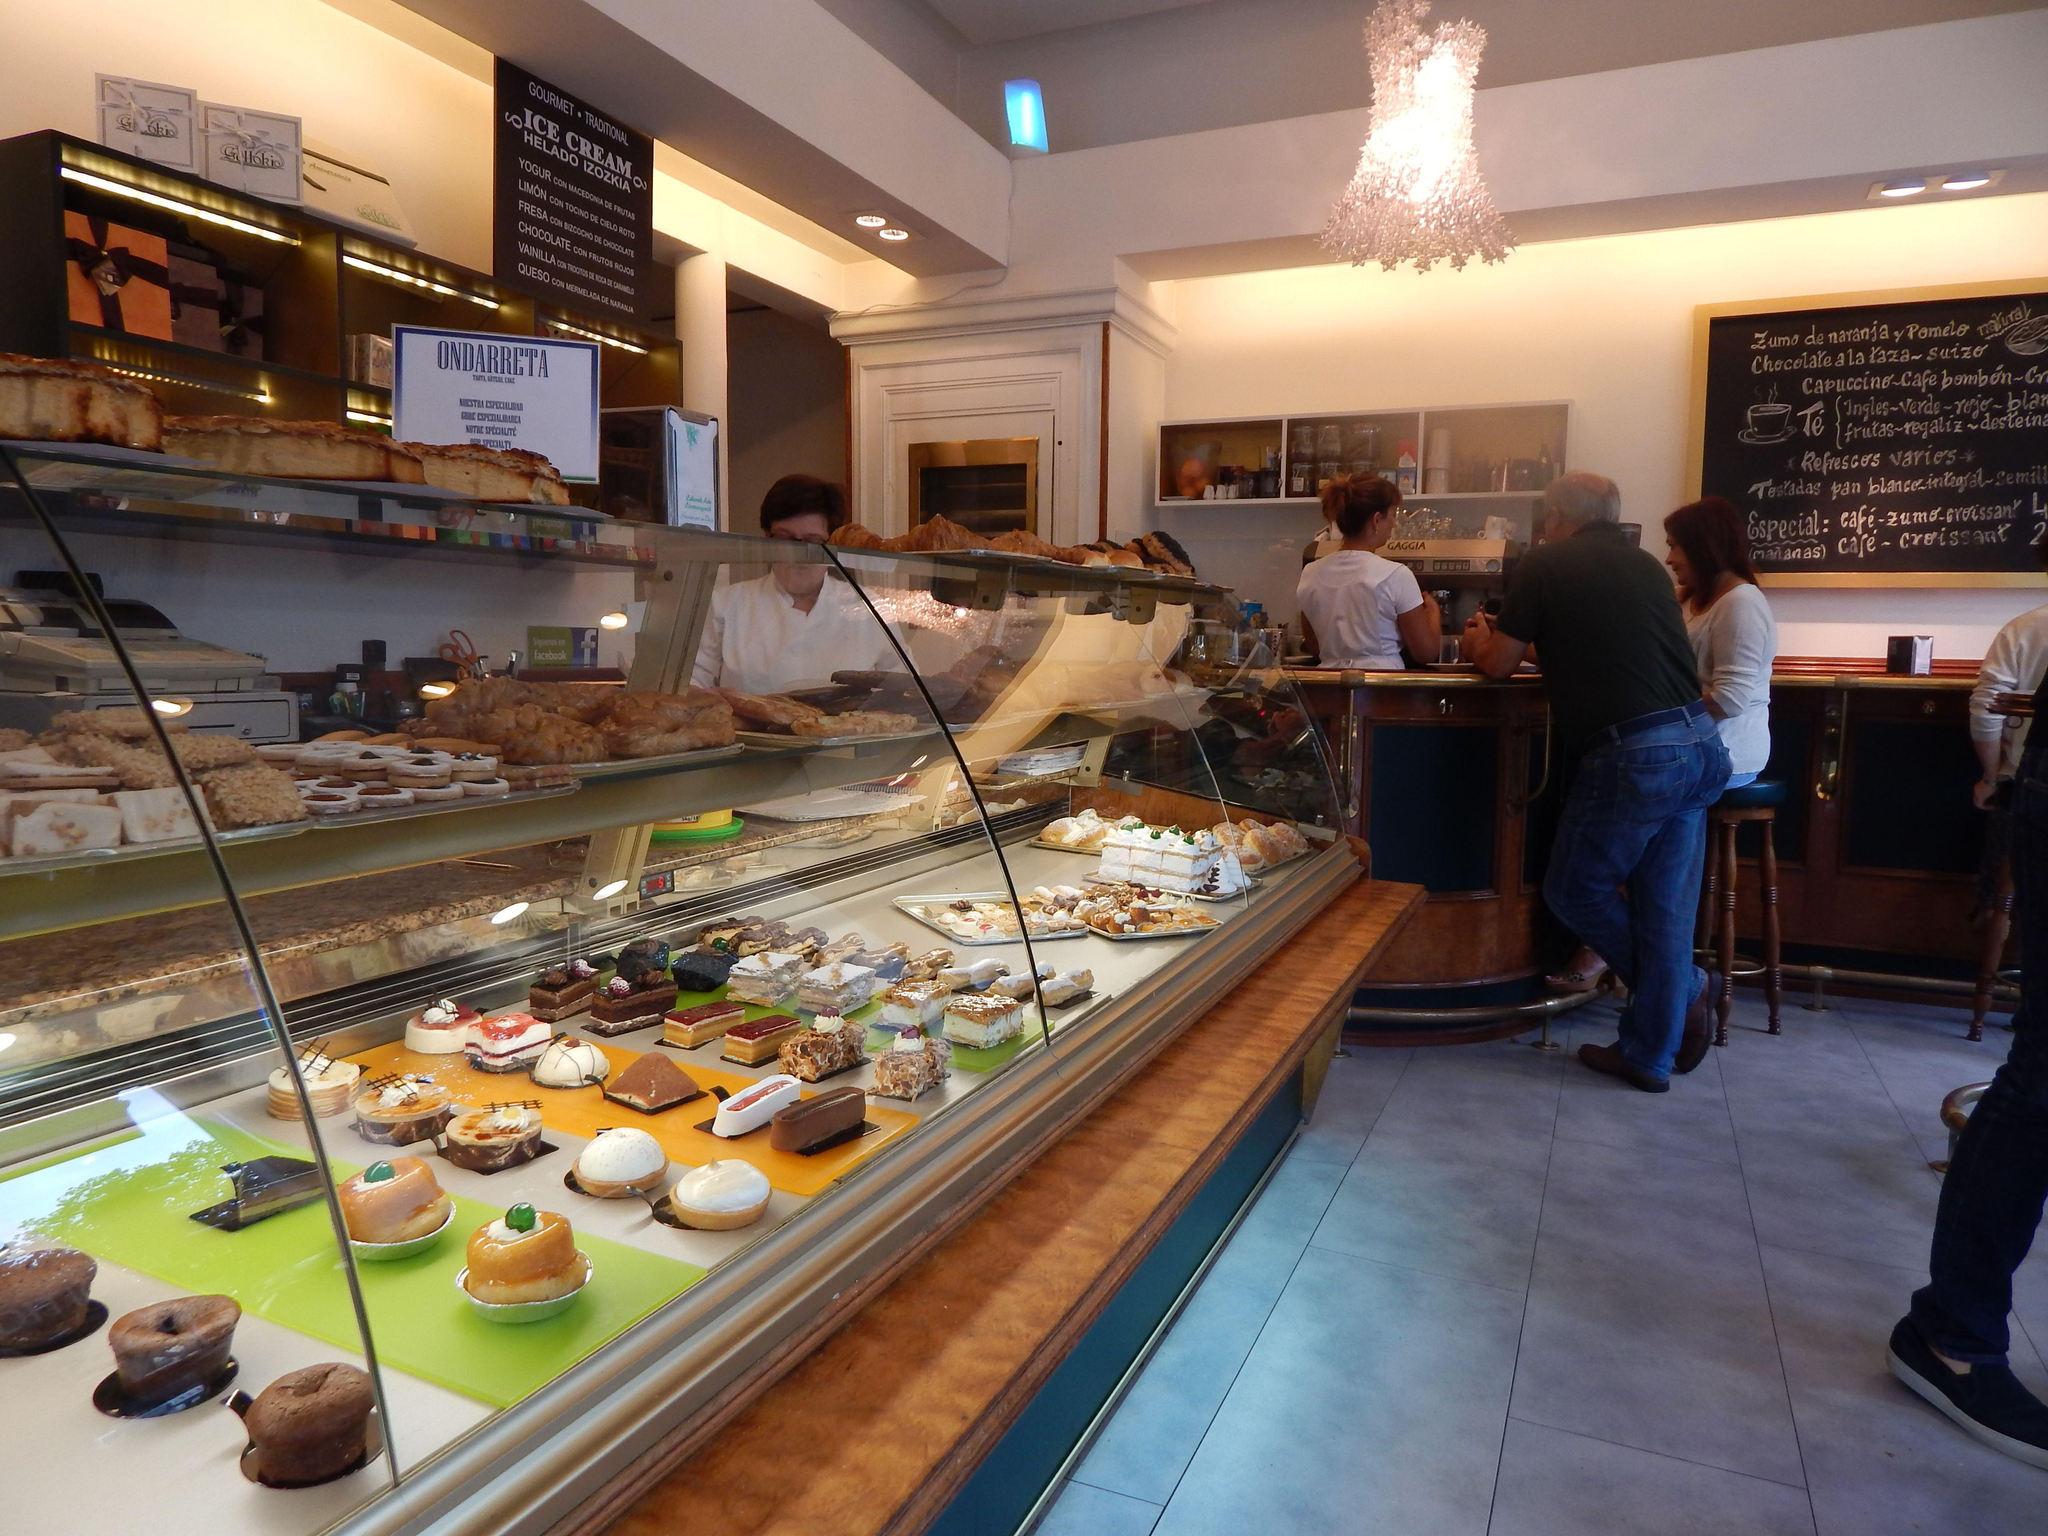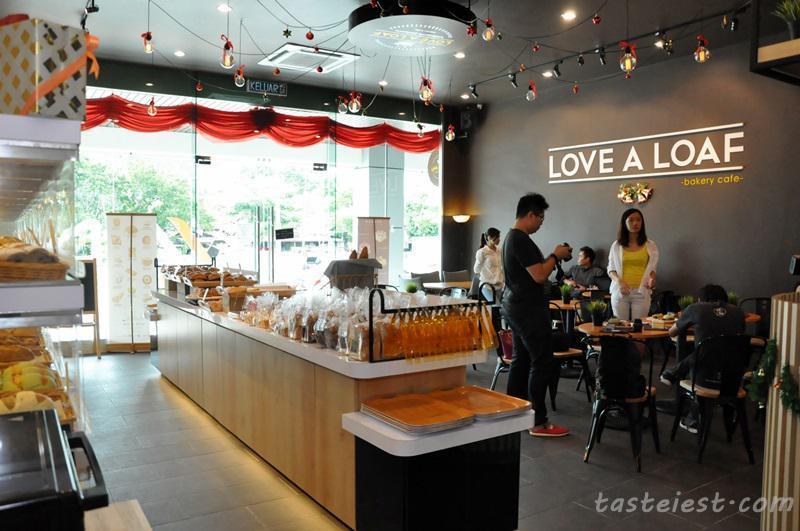The first image is the image on the left, the second image is the image on the right. Given the left and right images, does the statement "There are tables and chairs for dining in at least one of the images, but there are no people." hold true? Answer yes or no. Yes. 